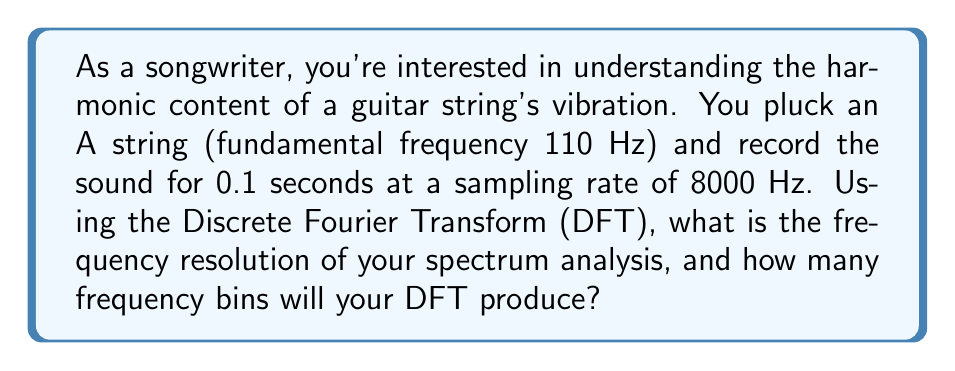Solve this math problem. Let's approach this step-by-step:

1) First, we need to understand what determines the frequency resolution in a DFT:
   The frequency resolution, $\Delta f$, is given by:
   
   $$\Delta f = \frac{f_s}{N}$$
   
   where $f_s$ is the sampling frequency and $N$ is the number of samples.

2) We're given:
   - Sampling rate (frequency): $f_s = 8000$ Hz
   - Recording duration: $T = 0.1$ seconds

3) To find $N$, we multiply the sampling rate by the duration:
   
   $$N = f_s \cdot T = 8000 \text{ Hz} \cdot 0.1 \text{ s} = 800 \text{ samples}$$

4) Now we can calculate the frequency resolution:
   
   $$\Delta f = \frac{f_s}{N} = \frac{8000 \text{ Hz}}{800} = 10 \text{ Hz}$$

5) For the number of frequency bins, the DFT produces N/2 + 1 unique frequency bins (including DC and Nyquist frequency):
   
   $$\text{Number of bins} = \frac{N}{2} + 1 = \frac{800}{2} + 1 = 401$$

Thus, the frequency resolution is 10 Hz, and the DFT will produce 401 frequency bins.
Answer: 10 Hz resolution, 401 frequency bins 